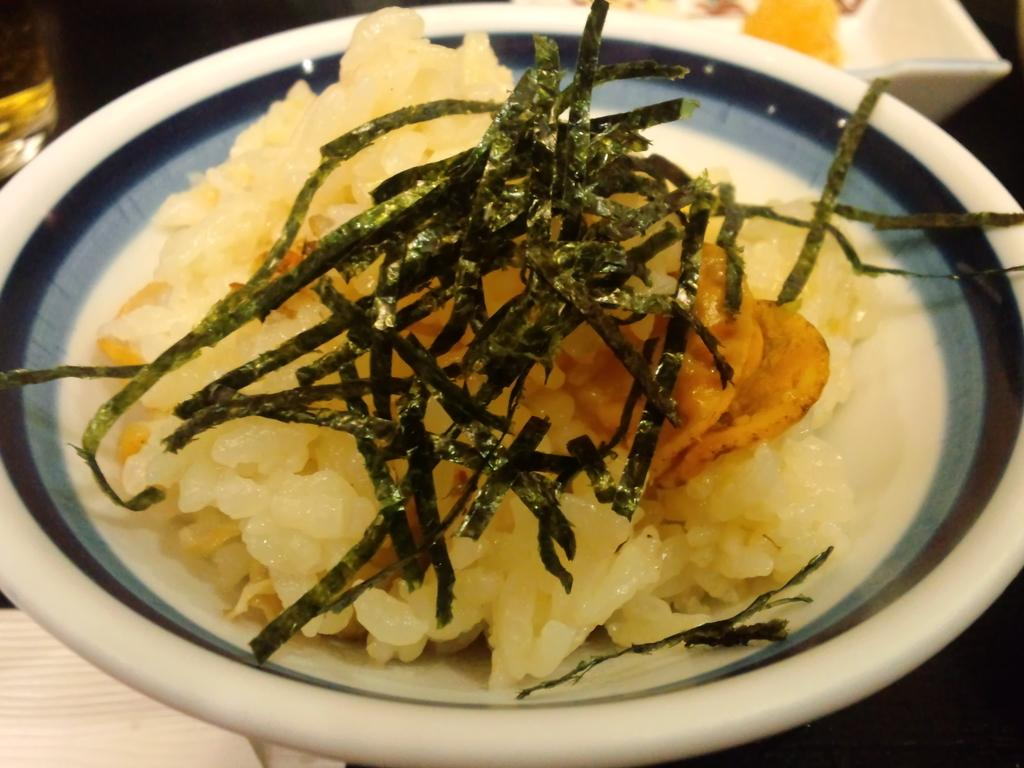What piece of furniture is present in the image? There is a table in the image. What is placed on the table? There is a plate on the table. What is on the plate? There is food in the plate. What is located behind the plate? There is a glass behind the plate. What type of rice is served in the silver dish in the image? There is no rice or silver dish present in the image. 